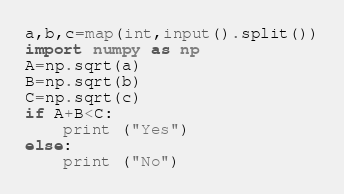<code> <loc_0><loc_0><loc_500><loc_500><_Python_>a,b,c=map(int,input().split())
import numpy as np
A=np.sqrt(a)
B=np.sqrt(b)
C=np.sqrt(c)
if A+B<C:
    print ("Yes")
else:
    print ("No")</code> 